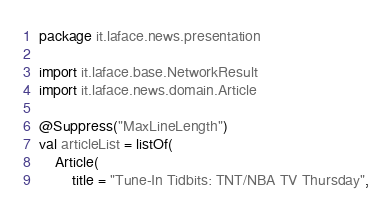Convert code to text. <code><loc_0><loc_0><loc_500><loc_500><_Kotlin_>package it.laface.news.presentation

import it.laface.base.NetworkResult
import it.laface.news.domain.Article

@Suppress("MaxLineLength")
val articleList = listOf(
    Article(
        title = "Tune-In Tidbits: TNT/NBA TV Thursday",</code> 